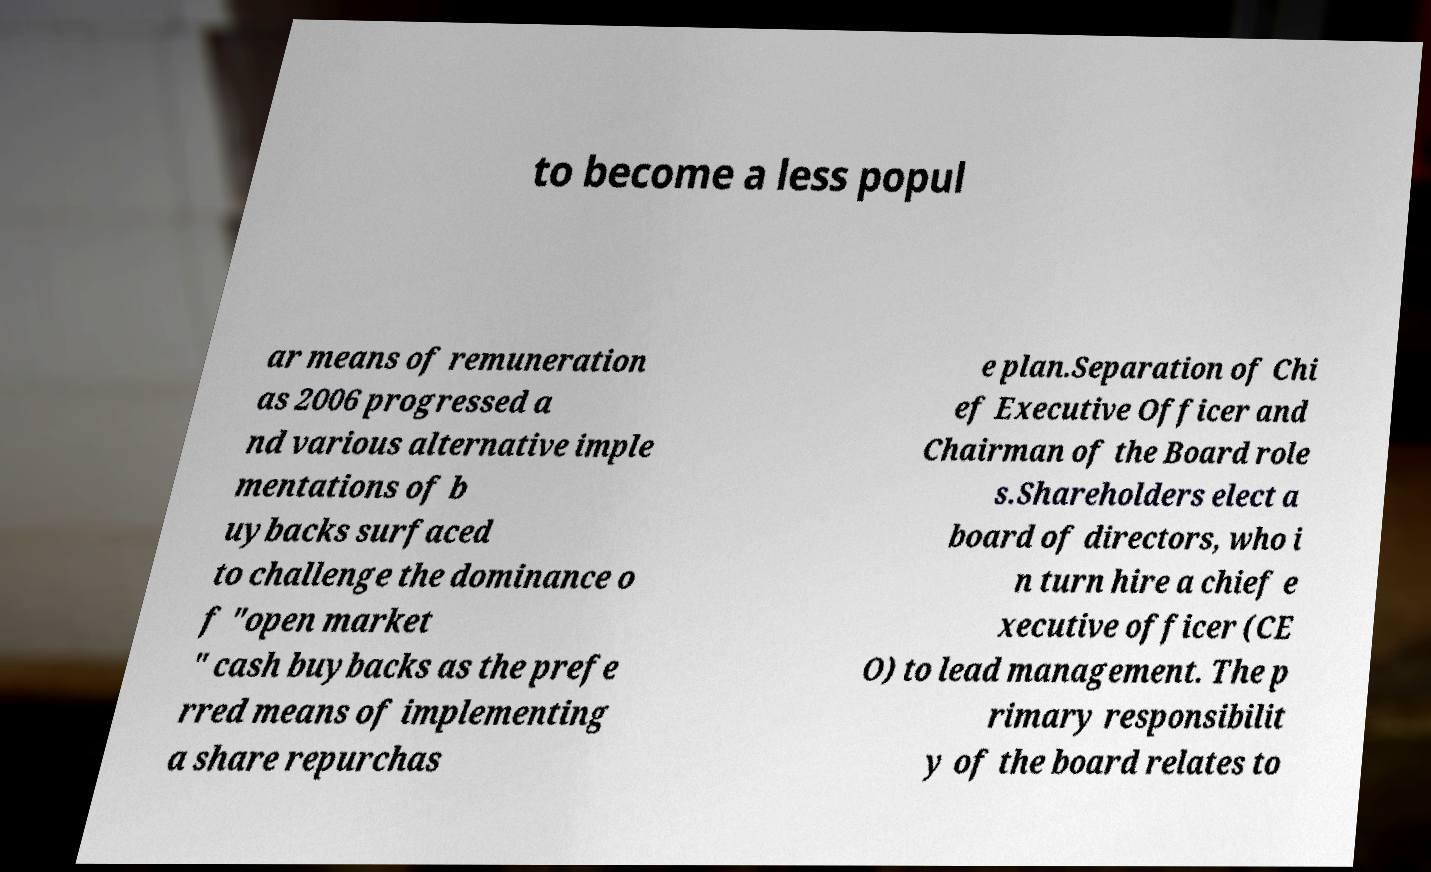I need the written content from this picture converted into text. Can you do that? to become a less popul ar means of remuneration as 2006 progressed a nd various alternative imple mentations of b uybacks surfaced to challenge the dominance o f "open market " cash buybacks as the prefe rred means of implementing a share repurchas e plan.Separation of Chi ef Executive Officer and Chairman of the Board role s.Shareholders elect a board of directors, who i n turn hire a chief e xecutive officer (CE O) to lead management. The p rimary responsibilit y of the board relates to 